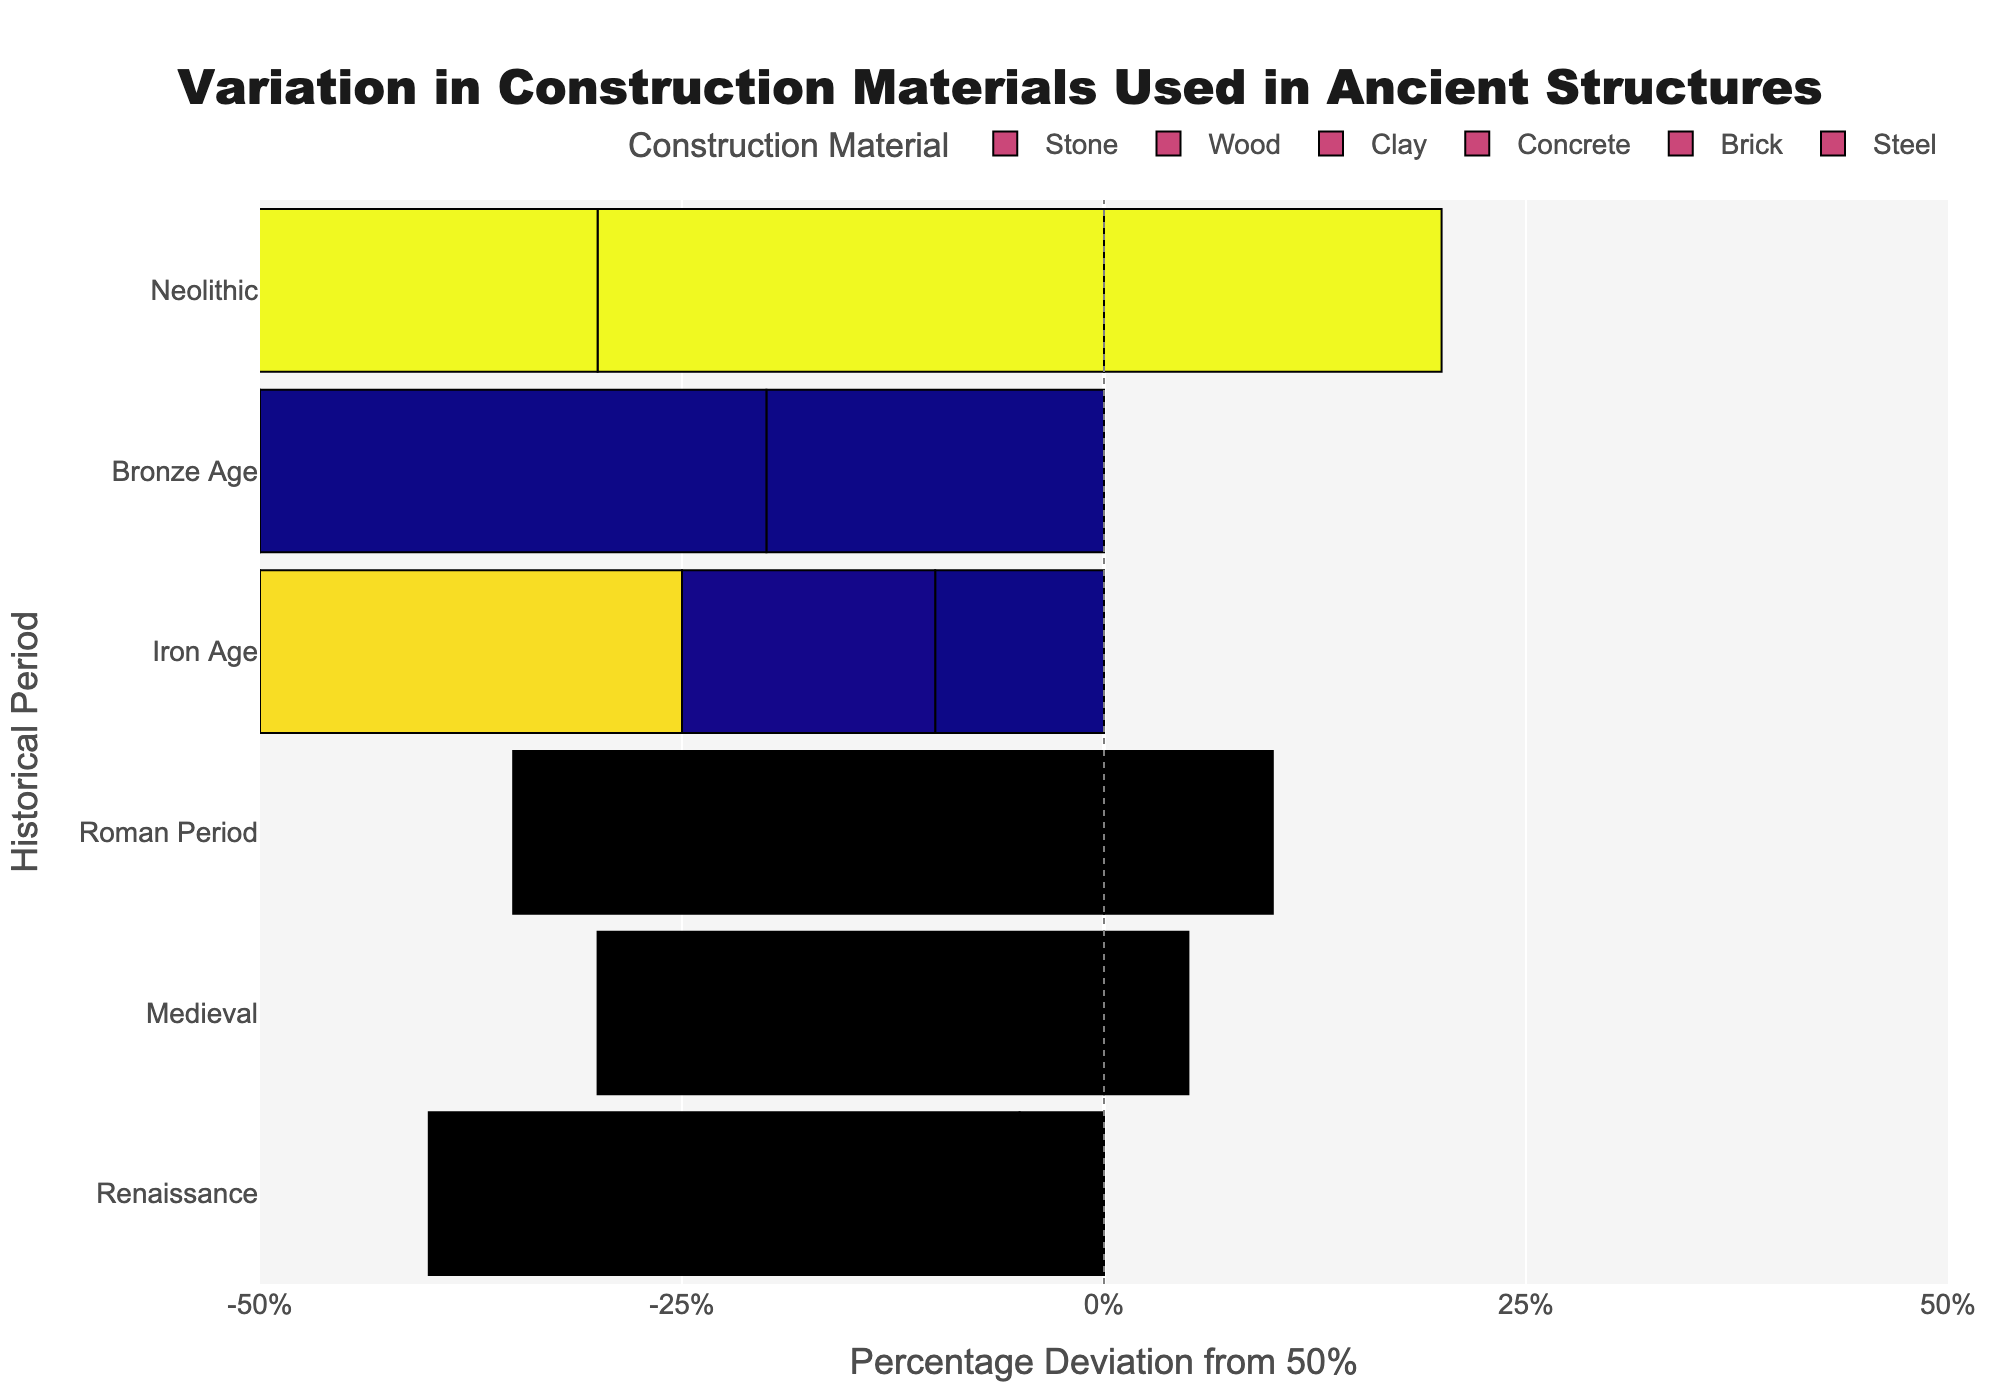Which period uses the highest percentage of steel? By observing the bars representing steel, identify which historical period has the highest percentage deviation from 50% for steel. Steel only appears in the Industrial Age period.
Answer: Industrial Age Which periods show concrete as a construction material and what are the corresponding percentages? Check for bars labeled as concrete and read the percentages for the corresponding periods. Concrete appears in the Roman Period and the Industrial Age. The percentages are 25% and 40% respectively.
Answer: Roman Period: 25%, Industrial Age: 40% In which period does clay have the highest percentage use? Look at the bars labeled clay across different periods and identify the one with the highest deviation from 50%. This is found by observing the longest bar. Bronze Age shows the highest use of clay.
Answer: Bronze Age Compare the use of stone between the Medieval and Renaissance periods. Which period has a higher percentage? Find the bars representing stone in both the Medieval and Renaissance periods and compare their lengths. Medieval has 55%, while Renaissance has 45%. The Medieval period has a higher percentage.
Answer: Medieval Calculate the average percentage use of wood across all periods. Sum the percentages of wood for each period and then divide by the number of periods that use wood. (20+30+35+15+20+15)/6 = 22.5
Answer: 22.5% What is the combined percentage of non-stone materials in the Industrial Age? Identify the percentages for brick, steel, and concrete in the Industrial Age, and sum them. (35 + 25 + 40) = 100
Answer: 100% Which period has the most variety in construction materials based on the number of different materials used? Count the number of different materials used in each period. The period with the highest count has the most variety. The Industrial Age, using steel, brick, and concrete, has three different materials.
Answer: Industrial Age Which material has seen a drastic change in use from the Iron Age to the Roman Period? Compare the percentage use of each material in both periods. Concrete appears in the Roman Period but not in the Iron Age, marking a drastic change.
Answer: Concrete 